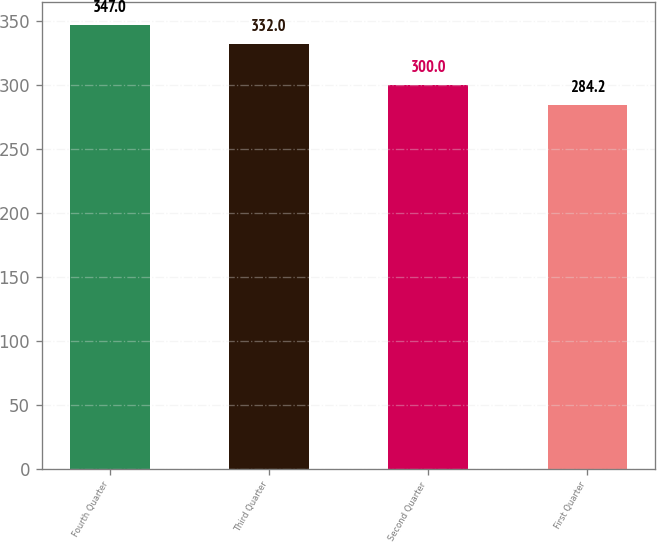Convert chart to OTSL. <chart><loc_0><loc_0><loc_500><loc_500><bar_chart><fcel>Fourth Quarter<fcel>Third Quarter<fcel>Second Quarter<fcel>First Quarter<nl><fcel>347<fcel>332<fcel>300<fcel>284.2<nl></chart> 